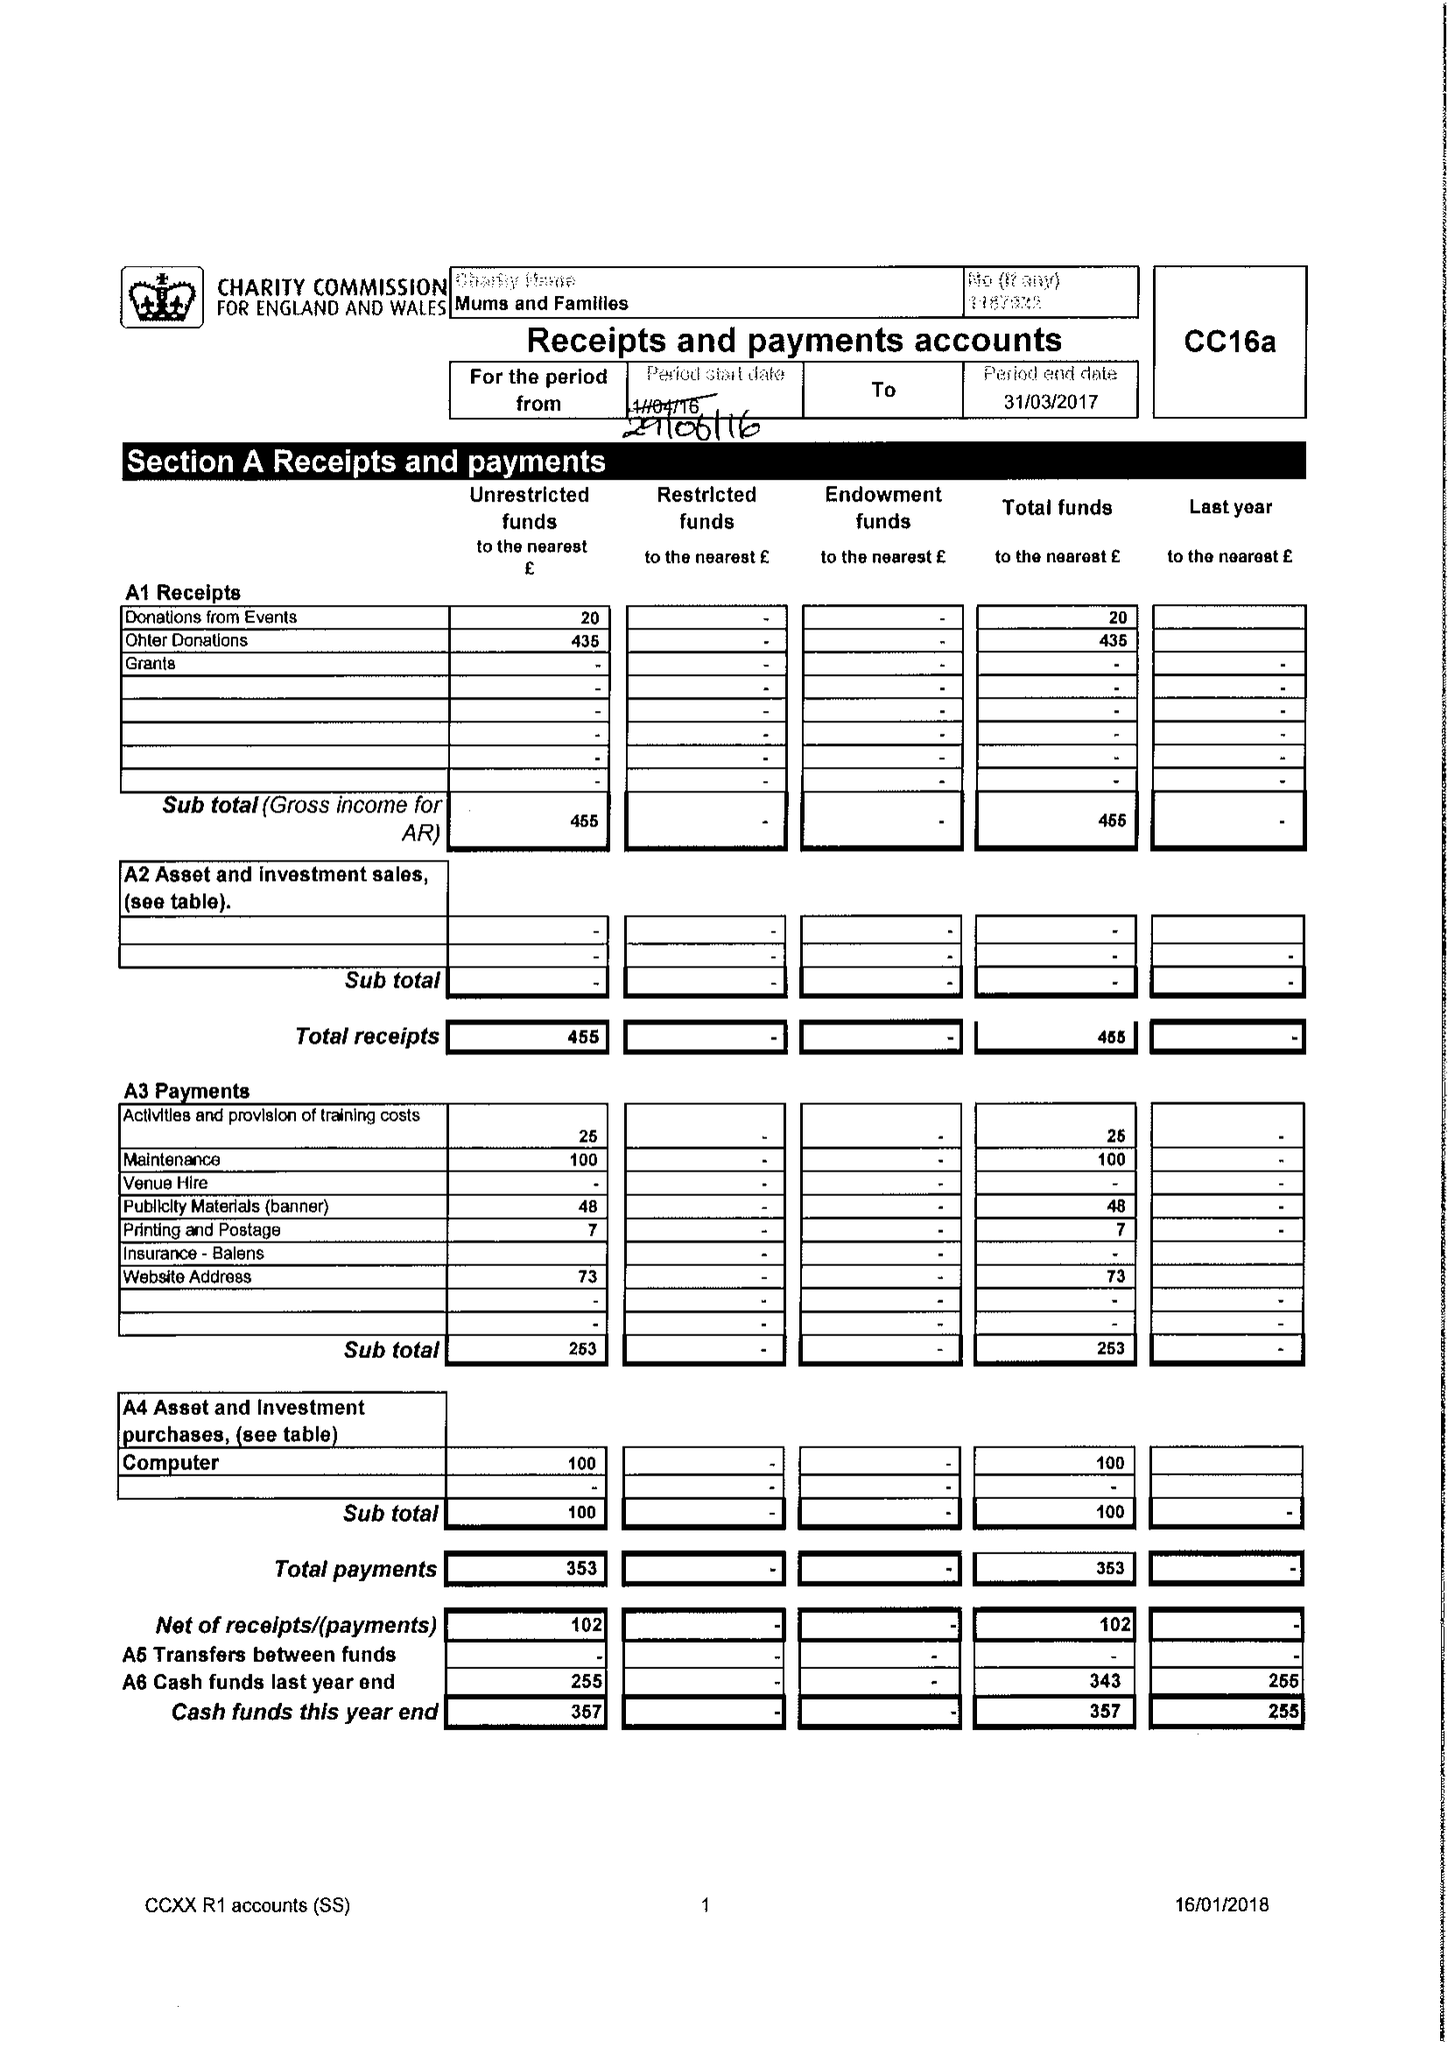What is the value for the address__post_town?
Answer the question using a single word or phrase. BIRMINGHAM 